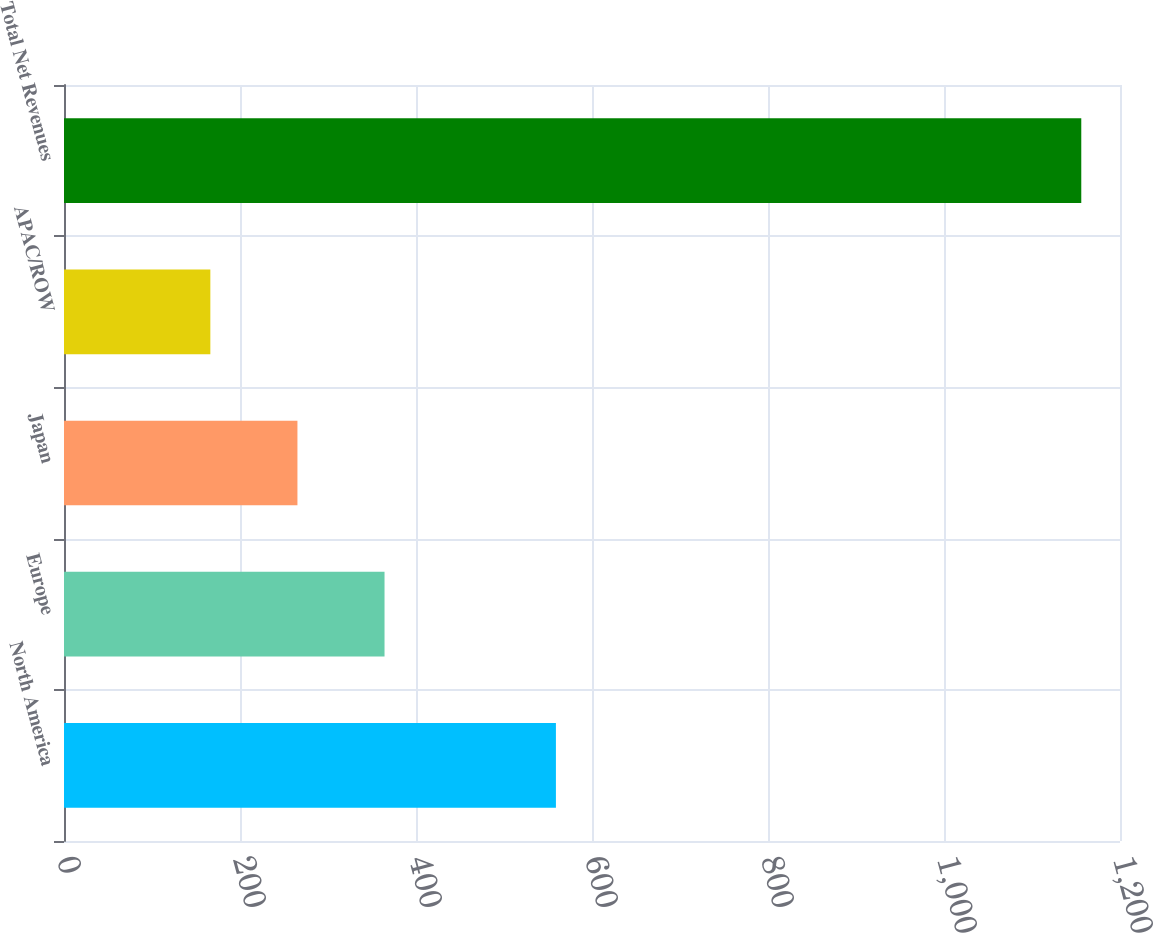Convert chart to OTSL. <chart><loc_0><loc_0><loc_500><loc_500><bar_chart><fcel>North America<fcel>Europe<fcel>Japan<fcel>APAC/ROW<fcel>Total Net Revenues<nl><fcel>559<fcel>364.24<fcel>265.27<fcel>166.3<fcel>1156<nl></chart> 